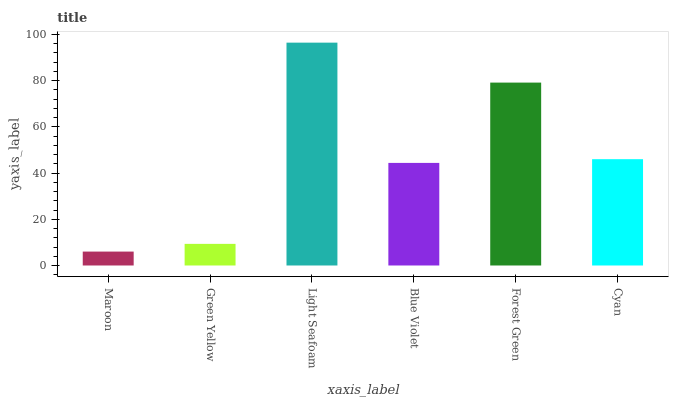Is Maroon the minimum?
Answer yes or no. Yes. Is Light Seafoam the maximum?
Answer yes or no. Yes. Is Green Yellow the minimum?
Answer yes or no. No. Is Green Yellow the maximum?
Answer yes or no. No. Is Green Yellow greater than Maroon?
Answer yes or no. Yes. Is Maroon less than Green Yellow?
Answer yes or no. Yes. Is Maroon greater than Green Yellow?
Answer yes or no. No. Is Green Yellow less than Maroon?
Answer yes or no. No. Is Cyan the high median?
Answer yes or no. Yes. Is Blue Violet the low median?
Answer yes or no. Yes. Is Light Seafoam the high median?
Answer yes or no. No. Is Maroon the low median?
Answer yes or no. No. 